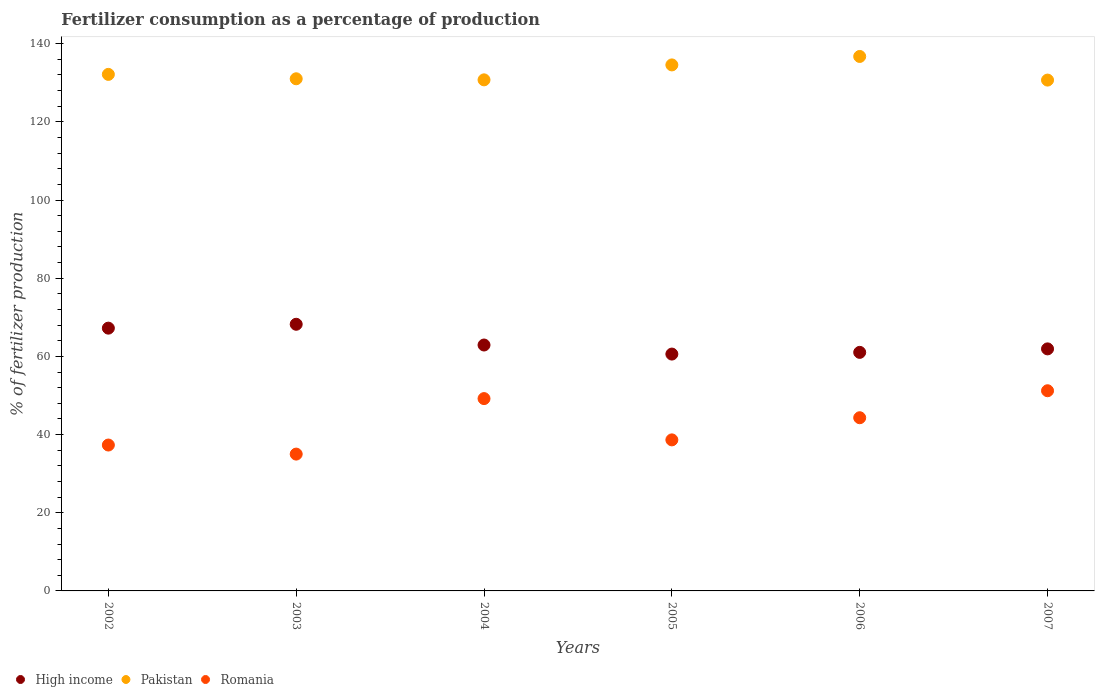How many different coloured dotlines are there?
Make the answer very short. 3. Is the number of dotlines equal to the number of legend labels?
Make the answer very short. Yes. What is the percentage of fertilizers consumed in Pakistan in 2005?
Ensure brevity in your answer.  134.56. Across all years, what is the maximum percentage of fertilizers consumed in Pakistan?
Offer a terse response. 136.72. Across all years, what is the minimum percentage of fertilizers consumed in Romania?
Offer a terse response. 35. In which year was the percentage of fertilizers consumed in Romania maximum?
Keep it short and to the point. 2007. In which year was the percentage of fertilizers consumed in Pakistan minimum?
Your response must be concise. 2007. What is the total percentage of fertilizers consumed in Romania in the graph?
Provide a succinct answer. 255.67. What is the difference between the percentage of fertilizers consumed in Romania in 2004 and that in 2006?
Provide a short and direct response. 4.9. What is the difference between the percentage of fertilizers consumed in Romania in 2004 and the percentage of fertilizers consumed in Pakistan in 2002?
Offer a very short reply. -82.94. What is the average percentage of fertilizers consumed in Romania per year?
Your answer should be compact. 42.61. In the year 2004, what is the difference between the percentage of fertilizers consumed in Pakistan and percentage of fertilizers consumed in Romania?
Give a very brief answer. 81.54. In how many years, is the percentage of fertilizers consumed in High income greater than 64 %?
Offer a terse response. 2. What is the ratio of the percentage of fertilizers consumed in Pakistan in 2003 to that in 2007?
Offer a terse response. 1. Is the percentage of fertilizers consumed in Romania in 2004 less than that in 2005?
Offer a terse response. No. Is the difference between the percentage of fertilizers consumed in Pakistan in 2003 and 2006 greater than the difference between the percentage of fertilizers consumed in Romania in 2003 and 2006?
Make the answer very short. Yes. What is the difference between the highest and the second highest percentage of fertilizers consumed in High income?
Provide a succinct answer. 0.99. What is the difference between the highest and the lowest percentage of fertilizers consumed in High income?
Provide a short and direct response. 7.62. In how many years, is the percentage of fertilizers consumed in Pakistan greater than the average percentage of fertilizers consumed in Pakistan taken over all years?
Give a very brief answer. 2. Is the sum of the percentage of fertilizers consumed in High income in 2002 and 2006 greater than the maximum percentage of fertilizers consumed in Pakistan across all years?
Keep it short and to the point. No. Is it the case that in every year, the sum of the percentage of fertilizers consumed in Romania and percentage of fertilizers consumed in Pakistan  is greater than the percentage of fertilizers consumed in High income?
Give a very brief answer. Yes. Does the percentage of fertilizers consumed in Romania monotonically increase over the years?
Provide a succinct answer. No. Is the percentage of fertilizers consumed in Romania strictly less than the percentage of fertilizers consumed in Pakistan over the years?
Ensure brevity in your answer.  Yes. Does the graph contain any zero values?
Your response must be concise. No. Does the graph contain grids?
Ensure brevity in your answer.  No. Where does the legend appear in the graph?
Ensure brevity in your answer.  Bottom left. How are the legend labels stacked?
Your answer should be compact. Horizontal. What is the title of the graph?
Give a very brief answer. Fertilizer consumption as a percentage of production. Does "Arab World" appear as one of the legend labels in the graph?
Offer a terse response. No. What is the label or title of the Y-axis?
Offer a terse response. % of fertilizer production. What is the % of fertilizer production in High income in 2002?
Your response must be concise. 67.22. What is the % of fertilizer production of Pakistan in 2002?
Give a very brief answer. 132.13. What is the % of fertilizer production in Romania in 2002?
Offer a terse response. 37.32. What is the % of fertilizer production of High income in 2003?
Make the answer very short. 68.21. What is the % of fertilizer production of Pakistan in 2003?
Offer a very short reply. 131.01. What is the % of fertilizer production of Romania in 2003?
Offer a terse response. 35. What is the % of fertilizer production of High income in 2004?
Provide a short and direct response. 62.91. What is the % of fertilizer production in Pakistan in 2004?
Keep it short and to the point. 130.73. What is the % of fertilizer production in Romania in 2004?
Your answer should be very brief. 49.2. What is the % of fertilizer production in High income in 2005?
Give a very brief answer. 60.59. What is the % of fertilizer production of Pakistan in 2005?
Provide a succinct answer. 134.56. What is the % of fertilizer production of Romania in 2005?
Make the answer very short. 38.64. What is the % of fertilizer production of High income in 2006?
Provide a succinct answer. 61.02. What is the % of fertilizer production in Pakistan in 2006?
Your answer should be very brief. 136.72. What is the % of fertilizer production of Romania in 2006?
Keep it short and to the point. 44.3. What is the % of fertilizer production of High income in 2007?
Your answer should be compact. 61.92. What is the % of fertilizer production in Pakistan in 2007?
Offer a terse response. 130.68. What is the % of fertilizer production of Romania in 2007?
Ensure brevity in your answer.  51.21. Across all years, what is the maximum % of fertilizer production in High income?
Provide a short and direct response. 68.21. Across all years, what is the maximum % of fertilizer production of Pakistan?
Keep it short and to the point. 136.72. Across all years, what is the maximum % of fertilizer production of Romania?
Your answer should be very brief. 51.21. Across all years, what is the minimum % of fertilizer production of High income?
Provide a short and direct response. 60.59. Across all years, what is the minimum % of fertilizer production of Pakistan?
Make the answer very short. 130.68. Across all years, what is the minimum % of fertilizer production of Romania?
Your answer should be compact. 35. What is the total % of fertilizer production of High income in the graph?
Your response must be concise. 381.87. What is the total % of fertilizer production in Pakistan in the graph?
Ensure brevity in your answer.  795.83. What is the total % of fertilizer production in Romania in the graph?
Your answer should be very brief. 255.67. What is the difference between the % of fertilizer production in High income in 2002 and that in 2003?
Provide a succinct answer. -0.99. What is the difference between the % of fertilizer production in Pakistan in 2002 and that in 2003?
Your answer should be very brief. 1.12. What is the difference between the % of fertilizer production in Romania in 2002 and that in 2003?
Offer a terse response. 2.32. What is the difference between the % of fertilizer production of High income in 2002 and that in 2004?
Offer a terse response. 4.31. What is the difference between the % of fertilizer production of Pakistan in 2002 and that in 2004?
Give a very brief answer. 1.4. What is the difference between the % of fertilizer production of Romania in 2002 and that in 2004?
Ensure brevity in your answer.  -11.88. What is the difference between the % of fertilizer production of High income in 2002 and that in 2005?
Give a very brief answer. 6.63. What is the difference between the % of fertilizer production in Pakistan in 2002 and that in 2005?
Your response must be concise. -2.42. What is the difference between the % of fertilizer production of Romania in 2002 and that in 2005?
Give a very brief answer. -1.32. What is the difference between the % of fertilizer production in High income in 2002 and that in 2006?
Your answer should be very brief. 6.2. What is the difference between the % of fertilizer production of Pakistan in 2002 and that in 2006?
Give a very brief answer. -4.59. What is the difference between the % of fertilizer production of Romania in 2002 and that in 2006?
Your response must be concise. -6.98. What is the difference between the % of fertilizer production in High income in 2002 and that in 2007?
Your answer should be very brief. 5.3. What is the difference between the % of fertilizer production in Pakistan in 2002 and that in 2007?
Your answer should be very brief. 1.46. What is the difference between the % of fertilizer production in Romania in 2002 and that in 2007?
Keep it short and to the point. -13.89. What is the difference between the % of fertilizer production of High income in 2003 and that in 2004?
Offer a terse response. 5.31. What is the difference between the % of fertilizer production in Pakistan in 2003 and that in 2004?
Keep it short and to the point. 0.28. What is the difference between the % of fertilizer production of Romania in 2003 and that in 2004?
Provide a succinct answer. -14.2. What is the difference between the % of fertilizer production in High income in 2003 and that in 2005?
Keep it short and to the point. 7.62. What is the difference between the % of fertilizer production in Pakistan in 2003 and that in 2005?
Your answer should be very brief. -3.55. What is the difference between the % of fertilizer production of Romania in 2003 and that in 2005?
Provide a short and direct response. -3.64. What is the difference between the % of fertilizer production in High income in 2003 and that in 2006?
Provide a succinct answer. 7.19. What is the difference between the % of fertilizer production of Pakistan in 2003 and that in 2006?
Keep it short and to the point. -5.71. What is the difference between the % of fertilizer production in Romania in 2003 and that in 2006?
Offer a very short reply. -9.3. What is the difference between the % of fertilizer production in High income in 2003 and that in 2007?
Keep it short and to the point. 6.3. What is the difference between the % of fertilizer production of Pakistan in 2003 and that in 2007?
Keep it short and to the point. 0.33. What is the difference between the % of fertilizer production in Romania in 2003 and that in 2007?
Offer a very short reply. -16.21. What is the difference between the % of fertilizer production of High income in 2004 and that in 2005?
Provide a succinct answer. 2.32. What is the difference between the % of fertilizer production in Pakistan in 2004 and that in 2005?
Provide a short and direct response. -3.82. What is the difference between the % of fertilizer production of Romania in 2004 and that in 2005?
Provide a succinct answer. 10.56. What is the difference between the % of fertilizer production of High income in 2004 and that in 2006?
Provide a short and direct response. 1.88. What is the difference between the % of fertilizer production in Pakistan in 2004 and that in 2006?
Your answer should be compact. -5.99. What is the difference between the % of fertilizer production in Romania in 2004 and that in 2006?
Provide a short and direct response. 4.9. What is the difference between the % of fertilizer production in High income in 2004 and that in 2007?
Provide a succinct answer. 0.99. What is the difference between the % of fertilizer production of Pakistan in 2004 and that in 2007?
Provide a short and direct response. 0.06. What is the difference between the % of fertilizer production of Romania in 2004 and that in 2007?
Ensure brevity in your answer.  -2.01. What is the difference between the % of fertilizer production in High income in 2005 and that in 2006?
Offer a very short reply. -0.44. What is the difference between the % of fertilizer production in Pakistan in 2005 and that in 2006?
Your answer should be very brief. -2.16. What is the difference between the % of fertilizer production in Romania in 2005 and that in 2006?
Your response must be concise. -5.66. What is the difference between the % of fertilizer production of High income in 2005 and that in 2007?
Make the answer very short. -1.33. What is the difference between the % of fertilizer production in Pakistan in 2005 and that in 2007?
Ensure brevity in your answer.  3.88. What is the difference between the % of fertilizer production in Romania in 2005 and that in 2007?
Your response must be concise. -12.57. What is the difference between the % of fertilizer production in High income in 2006 and that in 2007?
Provide a short and direct response. -0.89. What is the difference between the % of fertilizer production in Pakistan in 2006 and that in 2007?
Keep it short and to the point. 6.04. What is the difference between the % of fertilizer production of Romania in 2006 and that in 2007?
Offer a very short reply. -6.9. What is the difference between the % of fertilizer production in High income in 2002 and the % of fertilizer production in Pakistan in 2003?
Keep it short and to the point. -63.79. What is the difference between the % of fertilizer production in High income in 2002 and the % of fertilizer production in Romania in 2003?
Make the answer very short. 32.22. What is the difference between the % of fertilizer production of Pakistan in 2002 and the % of fertilizer production of Romania in 2003?
Provide a short and direct response. 97.13. What is the difference between the % of fertilizer production of High income in 2002 and the % of fertilizer production of Pakistan in 2004?
Your answer should be very brief. -63.51. What is the difference between the % of fertilizer production in High income in 2002 and the % of fertilizer production in Romania in 2004?
Make the answer very short. 18.02. What is the difference between the % of fertilizer production of Pakistan in 2002 and the % of fertilizer production of Romania in 2004?
Your response must be concise. 82.94. What is the difference between the % of fertilizer production of High income in 2002 and the % of fertilizer production of Pakistan in 2005?
Provide a short and direct response. -67.34. What is the difference between the % of fertilizer production of High income in 2002 and the % of fertilizer production of Romania in 2005?
Make the answer very short. 28.58. What is the difference between the % of fertilizer production of Pakistan in 2002 and the % of fertilizer production of Romania in 2005?
Ensure brevity in your answer.  93.5. What is the difference between the % of fertilizer production of High income in 2002 and the % of fertilizer production of Pakistan in 2006?
Ensure brevity in your answer.  -69.5. What is the difference between the % of fertilizer production in High income in 2002 and the % of fertilizer production in Romania in 2006?
Your answer should be compact. 22.92. What is the difference between the % of fertilizer production of Pakistan in 2002 and the % of fertilizer production of Romania in 2006?
Give a very brief answer. 87.83. What is the difference between the % of fertilizer production of High income in 2002 and the % of fertilizer production of Pakistan in 2007?
Your response must be concise. -63.46. What is the difference between the % of fertilizer production of High income in 2002 and the % of fertilizer production of Romania in 2007?
Ensure brevity in your answer.  16.01. What is the difference between the % of fertilizer production of Pakistan in 2002 and the % of fertilizer production of Romania in 2007?
Keep it short and to the point. 80.93. What is the difference between the % of fertilizer production of High income in 2003 and the % of fertilizer production of Pakistan in 2004?
Your answer should be very brief. -62.52. What is the difference between the % of fertilizer production in High income in 2003 and the % of fertilizer production in Romania in 2004?
Your answer should be compact. 19.01. What is the difference between the % of fertilizer production in Pakistan in 2003 and the % of fertilizer production in Romania in 2004?
Offer a terse response. 81.81. What is the difference between the % of fertilizer production of High income in 2003 and the % of fertilizer production of Pakistan in 2005?
Offer a terse response. -66.34. What is the difference between the % of fertilizer production of High income in 2003 and the % of fertilizer production of Romania in 2005?
Your response must be concise. 29.57. What is the difference between the % of fertilizer production in Pakistan in 2003 and the % of fertilizer production in Romania in 2005?
Your answer should be compact. 92.37. What is the difference between the % of fertilizer production of High income in 2003 and the % of fertilizer production of Pakistan in 2006?
Offer a very short reply. -68.51. What is the difference between the % of fertilizer production of High income in 2003 and the % of fertilizer production of Romania in 2006?
Your answer should be very brief. 23.91. What is the difference between the % of fertilizer production of Pakistan in 2003 and the % of fertilizer production of Romania in 2006?
Make the answer very short. 86.71. What is the difference between the % of fertilizer production in High income in 2003 and the % of fertilizer production in Pakistan in 2007?
Offer a very short reply. -62.46. What is the difference between the % of fertilizer production in High income in 2003 and the % of fertilizer production in Romania in 2007?
Offer a very short reply. 17.01. What is the difference between the % of fertilizer production of Pakistan in 2003 and the % of fertilizer production of Romania in 2007?
Offer a very short reply. 79.8. What is the difference between the % of fertilizer production of High income in 2004 and the % of fertilizer production of Pakistan in 2005?
Your response must be concise. -71.65. What is the difference between the % of fertilizer production of High income in 2004 and the % of fertilizer production of Romania in 2005?
Provide a short and direct response. 24.27. What is the difference between the % of fertilizer production of Pakistan in 2004 and the % of fertilizer production of Romania in 2005?
Provide a short and direct response. 92.1. What is the difference between the % of fertilizer production in High income in 2004 and the % of fertilizer production in Pakistan in 2006?
Make the answer very short. -73.82. What is the difference between the % of fertilizer production in High income in 2004 and the % of fertilizer production in Romania in 2006?
Your answer should be very brief. 18.6. What is the difference between the % of fertilizer production of Pakistan in 2004 and the % of fertilizer production of Romania in 2006?
Offer a very short reply. 86.43. What is the difference between the % of fertilizer production in High income in 2004 and the % of fertilizer production in Pakistan in 2007?
Provide a succinct answer. -67.77. What is the difference between the % of fertilizer production of High income in 2004 and the % of fertilizer production of Romania in 2007?
Make the answer very short. 11.7. What is the difference between the % of fertilizer production in Pakistan in 2004 and the % of fertilizer production in Romania in 2007?
Provide a short and direct response. 79.53. What is the difference between the % of fertilizer production of High income in 2005 and the % of fertilizer production of Pakistan in 2006?
Make the answer very short. -76.13. What is the difference between the % of fertilizer production in High income in 2005 and the % of fertilizer production in Romania in 2006?
Keep it short and to the point. 16.28. What is the difference between the % of fertilizer production in Pakistan in 2005 and the % of fertilizer production in Romania in 2006?
Your answer should be very brief. 90.25. What is the difference between the % of fertilizer production in High income in 2005 and the % of fertilizer production in Pakistan in 2007?
Your response must be concise. -70.09. What is the difference between the % of fertilizer production in High income in 2005 and the % of fertilizer production in Romania in 2007?
Your answer should be very brief. 9.38. What is the difference between the % of fertilizer production in Pakistan in 2005 and the % of fertilizer production in Romania in 2007?
Make the answer very short. 83.35. What is the difference between the % of fertilizer production in High income in 2006 and the % of fertilizer production in Pakistan in 2007?
Provide a short and direct response. -69.65. What is the difference between the % of fertilizer production of High income in 2006 and the % of fertilizer production of Romania in 2007?
Give a very brief answer. 9.82. What is the difference between the % of fertilizer production in Pakistan in 2006 and the % of fertilizer production in Romania in 2007?
Provide a succinct answer. 85.51. What is the average % of fertilizer production in High income per year?
Your response must be concise. 63.64. What is the average % of fertilizer production in Pakistan per year?
Offer a terse response. 132.64. What is the average % of fertilizer production in Romania per year?
Keep it short and to the point. 42.61. In the year 2002, what is the difference between the % of fertilizer production of High income and % of fertilizer production of Pakistan?
Give a very brief answer. -64.91. In the year 2002, what is the difference between the % of fertilizer production of High income and % of fertilizer production of Romania?
Ensure brevity in your answer.  29.9. In the year 2002, what is the difference between the % of fertilizer production of Pakistan and % of fertilizer production of Romania?
Offer a very short reply. 94.81. In the year 2003, what is the difference between the % of fertilizer production in High income and % of fertilizer production in Pakistan?
Your answer should be very brief. -62.8. In the year 2003, what is the difference between the % of fertilizer production of High income and % of fertilizer production of Romania?
Your answer should be compact. 33.21. In the year 2003, what is the difference between the % of fertilizer production of Pakistan and % of fertilizer production of Romania?
Your response must be concise. 96.01. In the year 2004, what is the difference between the % of fertilizer production of High income and % of fertilizer production of Pakistan?
Your response must be concise. -67.83. In the year 2004, what is the difference between the % of fertilizer production of High income and % of fertilizer production of Romania?
Offer a terse response. 13.71. In the year 2004, what is the difference between the % of fertilizer production in Pakistan and % of fertilizer production in Romania?
Offer a terse response. 81.54. In the year 2005, what is the difference between the % of fertilizer production in High income and % of fertilizer production in Pakistan?
Ensure brevity in your answer.  -73.97. In the year 2005, what is the difference between the % of fertilizer production of High income and % of fertilizer production of Romania?
Give a very brief answer. 21.95. In the year 2005, what is the difference between the % of fertilizer production in Pakistan and % of fertilizer production in Romania?
Your answer should be compact. 95.92. In the year 2006, what is the difference between the % of fertilizer production in High income and % of fertilizer production in Pakistan?
Make the answer very short. -75.7. In the year 2006, what is the difference between the % of fertilizer production in High income and % of fertilizer production in Romania?
Provide a short and direct response. 16.72. In the year 2006, what is the difference between the % of fertilizer production of Pakistan and % of fertilizer production of Romania?
Offer a very short reply. 92.42. In the year 2007, what is the difference between the % of fertilizer production of High income and % of fertilizer production of Pakistan?
Keep it short and to the point. -68.76. In the year 2007, what is the difference between the % of fertilizer production in High income and % of fertilizer production in Romania?
Your answer should be compact. 10.71. In the year 2007, what is the difference between the % of fertilizer production in Pakistan and % of fertilizer production in Romania?
Provide a short and direct response. 79.47. What is the ratio of the % of fertilizer production of High income in 2002 to that in 2003?
Ensure brevity in your answer.  0.99. What is the ratio of the % of fertilizer production in Pakistan in 2002 to that in 2003?
Make the answer very short. 1.01. What is the ratio of the % of fertilizer production in Romania in 2002 to that in 2003?
Your answer should be compact. 1.07. What is the ratio of the % of fertilizer production in High income in 2002 to that in 2004?
Keep it short and to the point. 1.07. What is the ratio of the % of fertilizer production in Pakistan in 2002 to that in 2004?
Give a very brief answer. 1.01. What is the ratio of the % of fertilizer production of Romania in 2002 to that in 2004?
Offer a terse response. 0.76. What is the ratio of the % of fertilizer production in High income in 2002 to that in 2005?
Offer a very short reply. 1.11. What is the ratio of the % of fertilizer production of Romania in 2002 to that in 2005?
Offer a terse response. 0.97. What is the ratio of the % of fertilizer production of High income in 2002 to that in 2006?
Give a very brief answer. 1.1. What is the ratio of the % of fertilizer production in Pakistan in 2002 to that in 2006?
Keep it short and to the point. 0.97. What is the ratio of the % of fertilizer production in Romania in 2002 to that in 2006?
Provide a short and direct response. 0.84. What is the ratio of the % of fertilizer production of High income in 2002 to that in 2007?
Provide a short and direct response. 1.09. What is the ratio of the % of fertilizer production in Pakistan in 2002 to that in 2007?
Give a very brief answer. 1.01. What is the ratio of the % of fertilizer production in Romania in 2002 to that in 2007?
Your answer should be compact. 0.73. What is the ratio of the % of fertilizer production of High income in 2003 to that in 2004?
Ensure brevity in your answer.  1.08. What is the ratio of the % of fertilizer production in Pakistan in 2003 to that in 2004?
Offer a very short reply. 1. What is the ratio of the % of fertilizer production in Romania in 2003 to that in 2004?
Give a very brief answer. 0.71. What is the ratio of the % of fertilizer production in High income in 2003 to that in 2005?
Provide a succinct answer. 1.13. What is the ratio of the % of fertilizer production of Pakistan in 2003 to that in 2005?
Your response must be concise. 0.97. What is the ratio of the % of fertilizer production in Romania in 2003 to that in 2005?
Give a very brief answer. 0.91. What is the ratio of the % of fertilizer production in High income in 2003 to that in 2006?
Make the answer very short. 1.12. What is the ratio of the % of fertilizer production of Pakistan in 2003 to that in 2006?
Make the answer very short. 0.96. What is the ratio of the % of fertilizer production of Romania in 2003 to that in 2006?
Give a very brief answer. 0.79. What is the ratio of the % of fertilizer production of High income in 2003 to that in 2007?
Provide a succinct answer. 1.1. What is the ratio of the % of fertilizer production in Pakistan in 2003 to that in 2007?
Make the answer very short. 1. What is the ratio of the % of fertilizer production in Romania in 2003 to that in 2007?
Provide a short and direct response. 0.68. What is the ratio of the % of fertilizer production in High income in 2004 to that in 2005?
Give a very brief answer. 1.04. What is the ratio of the % of fertilizer production of Pakistan in 2004 to that in 2005?
Provide a succinct answer. 0.97. What is the ratio of the % of fertilizer production of Romania in 2004 to that in 2005?
Give a very brief answer. 1.27. What is the ratio of the % of fertilizer production in High income in 2004 to that in 2006?
Offer a very short reply. 1.03. What is the ratio of the % of fertilizer production of Pakistan in 2004 to that in 2006?
Your answer should be compact. 0.96. What is the ratio of the % of fertilizer production of Romania in 2004 to that in 2006?
Make the answer very short. 1.11. What is the ratio of the % of fertilizer production in Romania in 2004 to that in 2007?
Give a very brief answer. 0.96. What is the ratio of the % of fertilizer production in High income in 2005 to that in 2006?
Your answer should be very brief. 0.99. What is the ratio of the % of fertilizer production in Pakistan in 2005 to that in 2006?
Make the answer very short. 0.98. What is the ratio of the % of fertilizer production of Romania in 2005 to that in 2006?
Your response must be concise. 0.87. What is the ratio of the % of fertilizer production of High income in 2005 to that in 2007?
Your answer should be very brief. 0.98. What is the ratio of the % of fertilizer production of Pakistan in 2005 to that in 2007?
Your response must be concise. 1.03. What is the ratio of the % of fertilizer production of Romania in 2005 to that in 2007?
Provide a short and direct response. 0.75. What is the ratio of the % of fertilizer production in High income in 2006 to that in 2007?
Offer a very short reply. 0.99. What is the ratio of the % of fertilizer production of Pakistan in 2006 to that in 2007?
Offer a terse response. 1.05. What is the ratio of the % of fertilizer production of Romania in 2006 to that in 2007?
Give a very brief answer. 0.87. What is the difference between the highest and the second highest % of fertilizer production in Pakistan?
Your answer should be compact. 2.16. What is the difference between the highest and the second highest % of fertilizer production in Romania?
Your answer should be very brief. 2.01. What is the difference between the highest and the lowest % of fertilizer production in High income?
Give a very brief answer. 7.62. What is the difference between the highest and the lowest % of fertilizer production in Pakistan?
Provide a short and direct response. 6.04. What is the difference between the highest and the lowest % of fertilizer production of Romania?
Offer a very short reply. 16.21. 